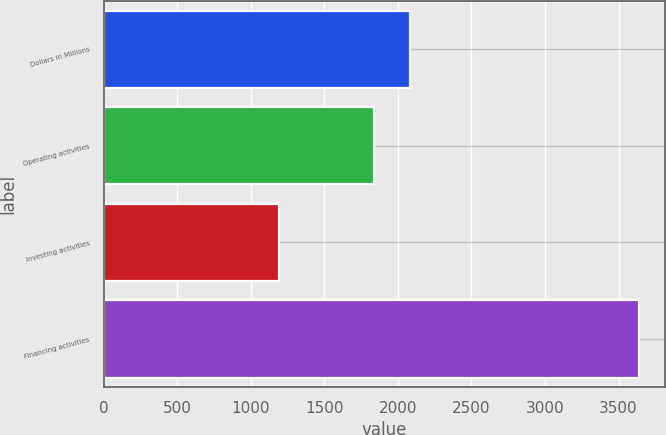Convert chart. <chart><loc_0><loc_0><loc_500><loc_500><bar_chart><fcel>Dollars in Millions<fcel>Operating activities<fcel>Investing activities<fcel>Financing activities<nl><fcel>2080.6<fcel>1836<fcel>1191<fcel>3637<nl></chart> 